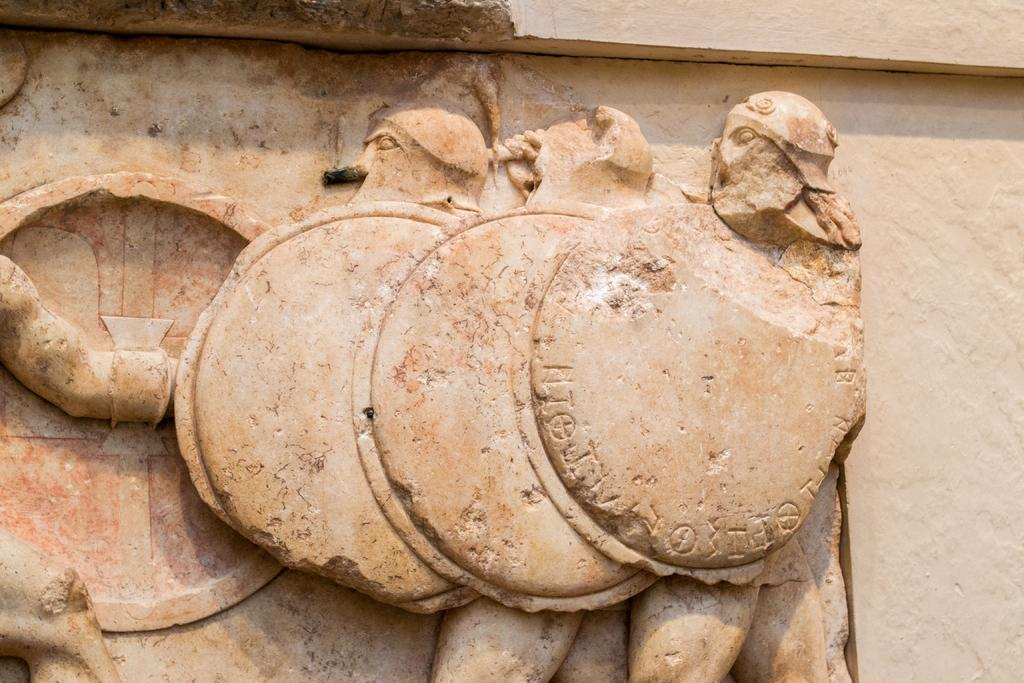What is the main subject of the image? The main subject of the image is a sculpture on the wall. Can you describe the sculpture in the image? Unfortunately, the provided facts do not include a description of the sculpture. Where is the sculpture located in the image? The sculpture is located on the wall in the image. What type of underwear is the sculpture wearing in the image? The provided facts do not mention any underwear, and the image does not depict a sculpture wearing underwear. 